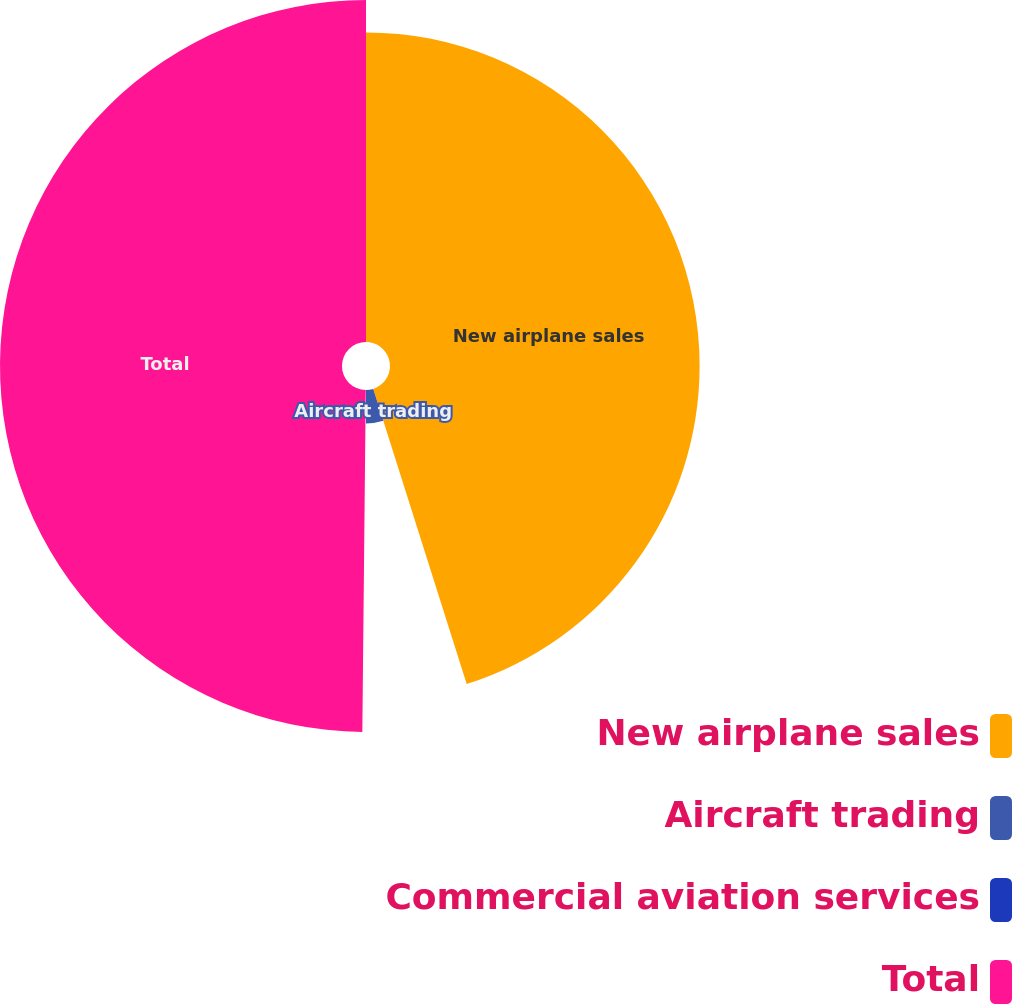<chart> <loc_0><loc_0><loc_500><loc_500><pie_chart><fcel>New airplane sales<fcel>Aircraft trading<fcel>Commercial aviation services<fcel>Total<nl><fcel>45.12%<fcel>4.88%<fcel>0.16%<fcel>49.84%<nl></chart> 